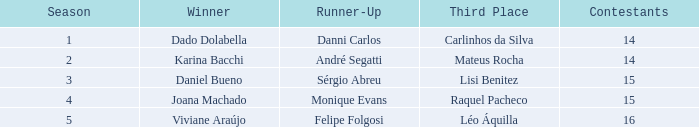How many contenders were involved when monique evans secured the second position? 15.0. 